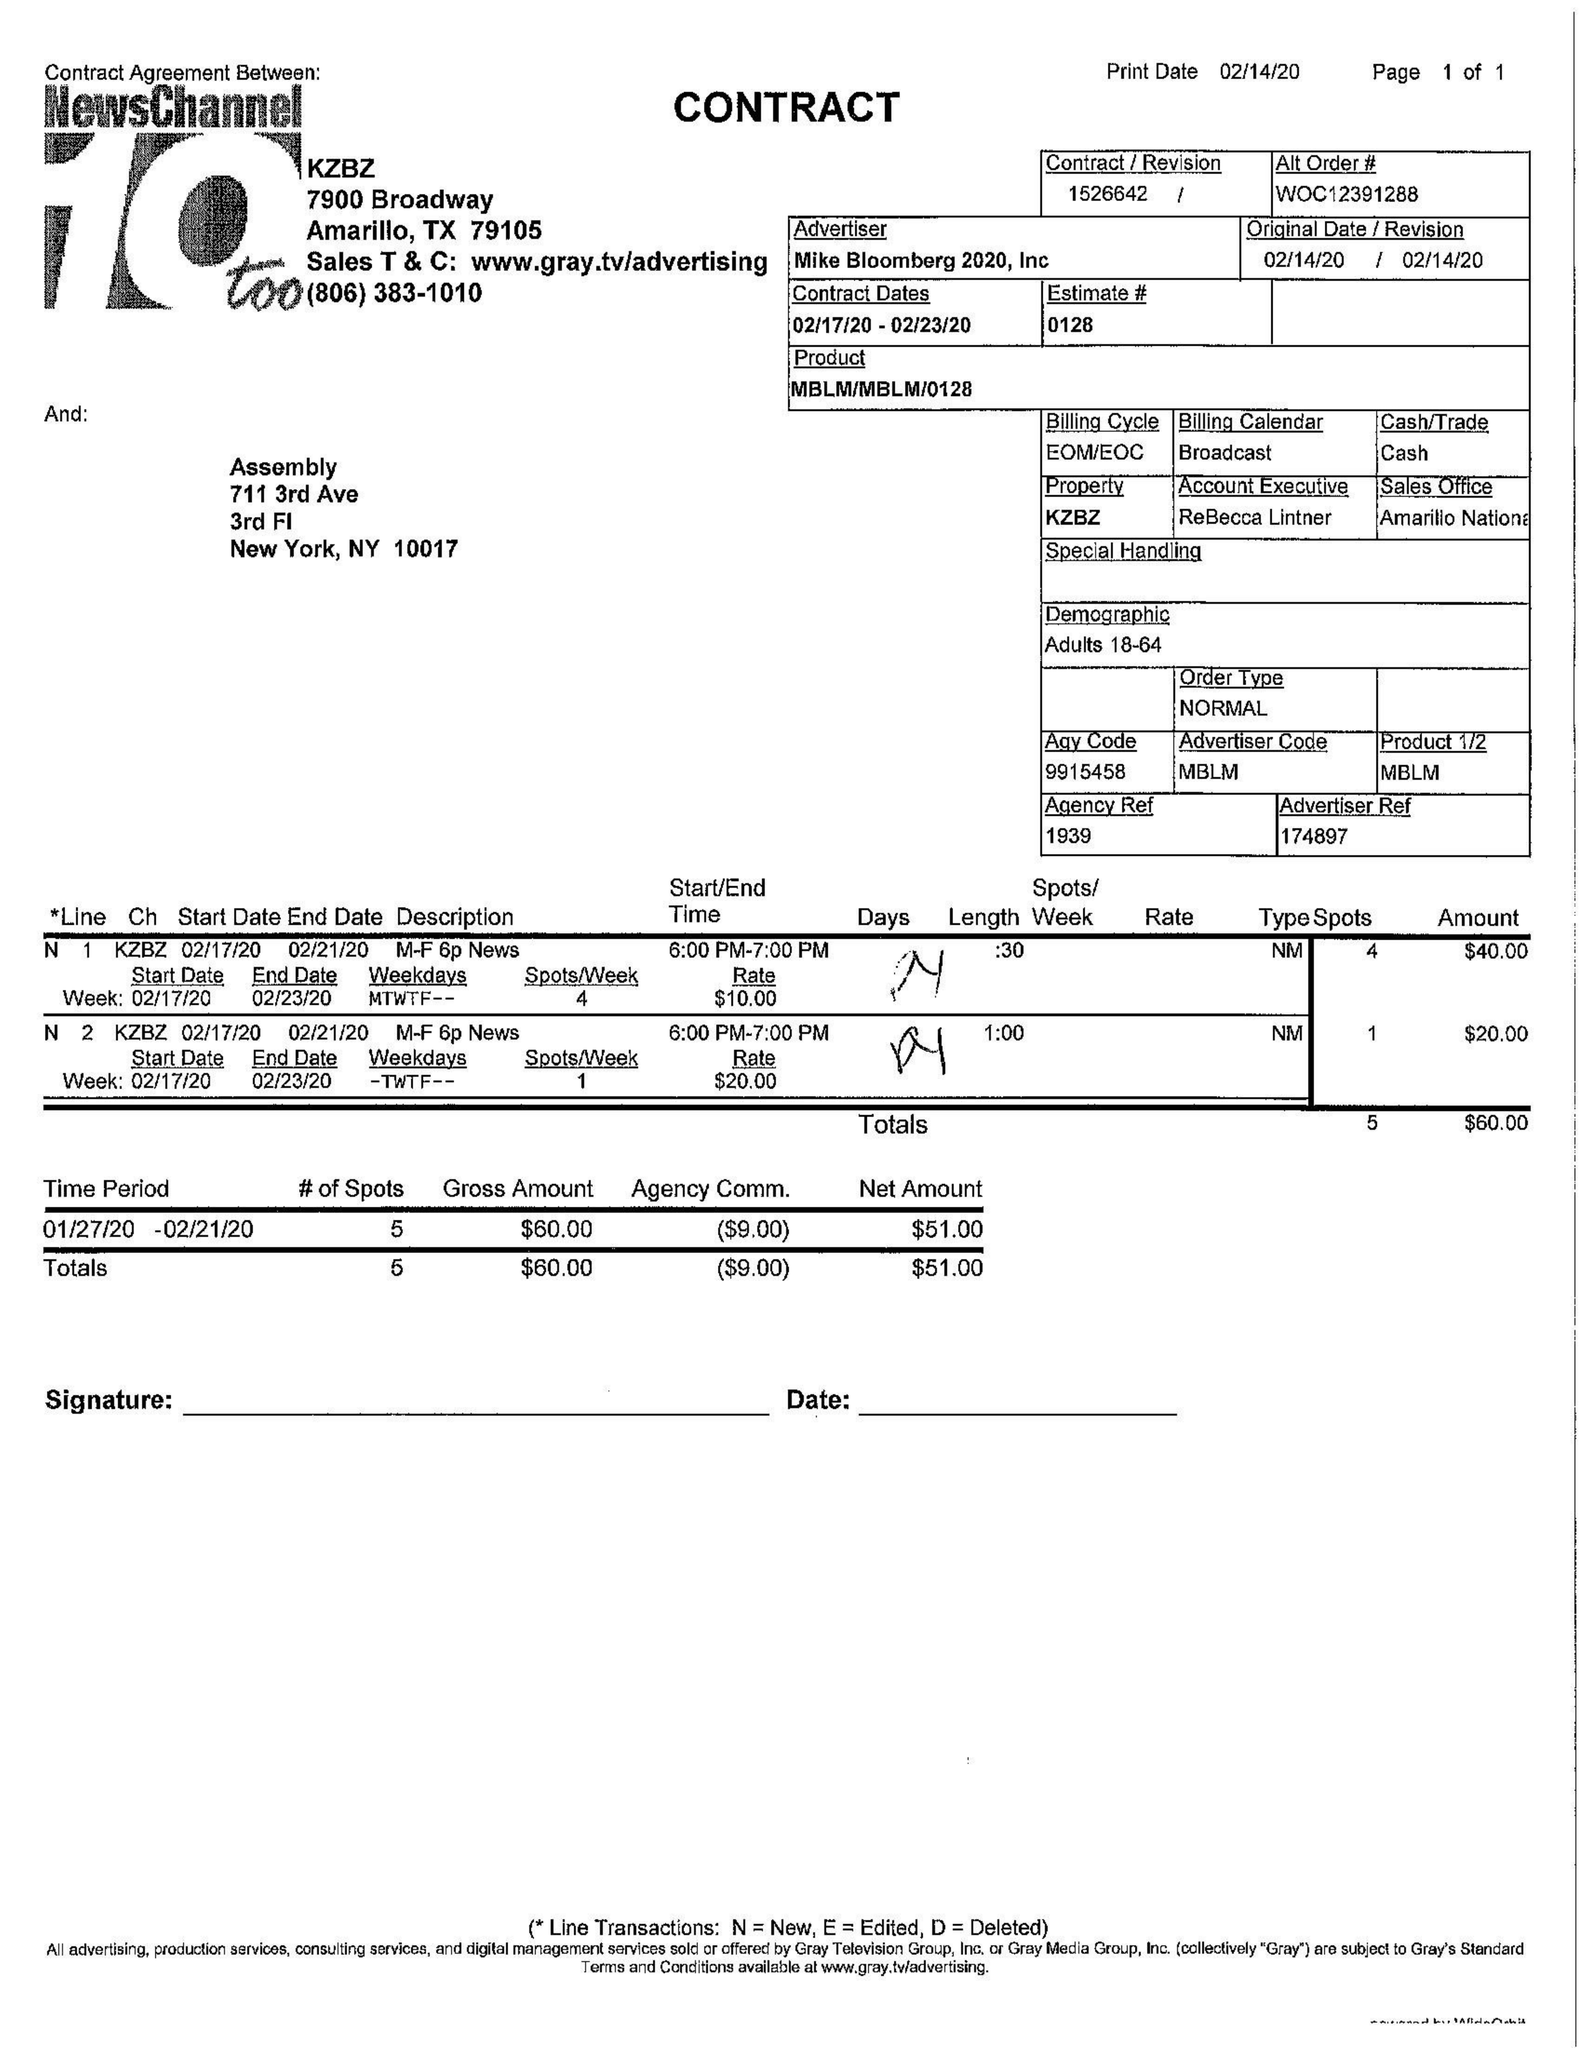What is the value for the gross_amount?
Answer the question using a single word or phrase. 60.00 